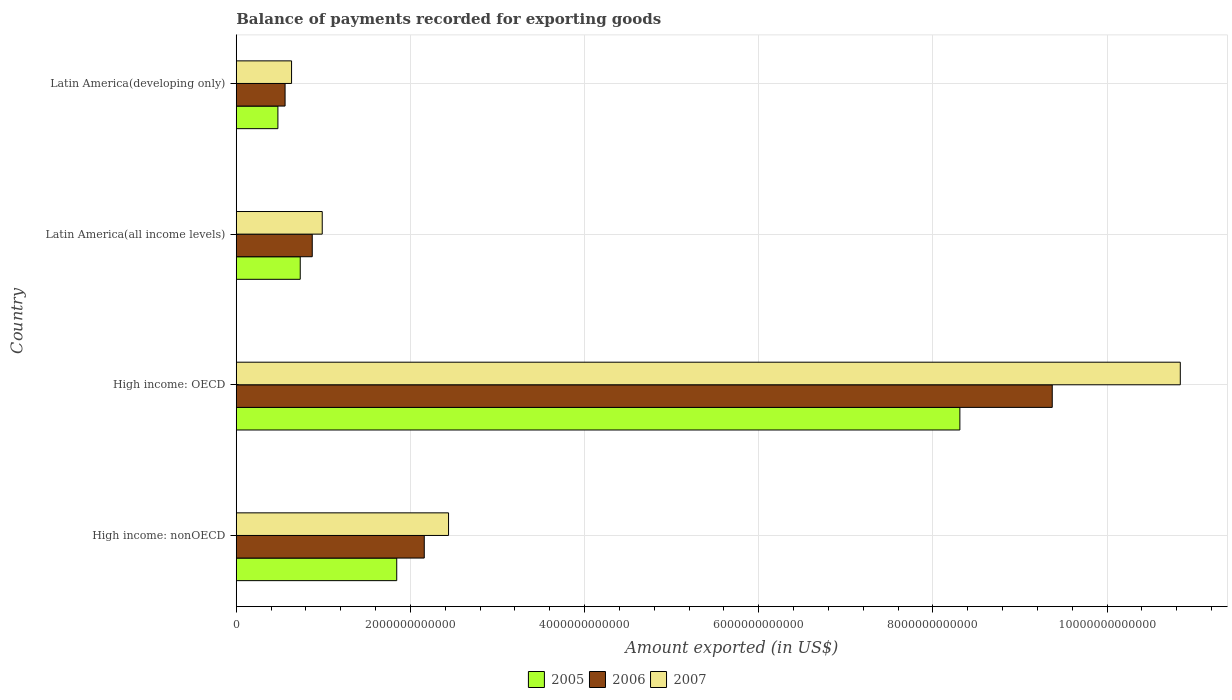How many different coloured bars are there?
Keep it short and to the point. 3. How many groups of bars are there?
Provide a succinct answer. 4. How many bars are there on the 3rd tick from the bottom?
Give a very brief answer. 3. What is the label of the 1st group of bars from the top?
Provide a short and direct response. Latin America(developing only). In how many cases, is the number of bars for a given country not equal to the number of legend labels?
Your answer should be compact. 0. What is the amount exported in 2007 in High income: OECD?
Make the answer very short. 1.08e+13. Across all countries, what is the maximum amount exported in 2005?
Your answer should be very brief. 8.31e+12. Across all countries, what is the minimum amount exported in 2006?
Make the answer very short. 5.61e+11. In which country was the amount exported in 2007 maximum?
Keep it short and to the point. High income: OECD. In which country was the amount exported in 2005 minimum?
Make the answer very short. Latin America(developing only). What is the total amount exported in 2006 in the graph?
Offer a very short reply. 1.30e+13. What is the difference between the amount exported in 2005 in High income: OECD and that in Latin America(developing only)?
Make the answer very short. 7.83e+12. What is the difference between the amount exported in 2007 in High income: OECD and the amount exported in 2005 in Latin America(all income levels)?
Make the answer very short. 1.01e+13. What is the average amount exported in 2007 per country?
Offer a terse response. 3.73e+12. What is the difference between the amount exported in 2006 and amount exported in 2007 in Latin America(developing only)?
Your answer should be very brief. -7.45e+1. What is the ratio of the amount exported in 2007 in High income: OECD to that in Latin America(developing only)?
Keep it short and to the point. 17.07. Is the amount exported in 2007 in Latin America(all income levels) less than that in Latin America(developing only)?
Keep it short and to the point. No. Is the difference between the amount exported in 2006 in High income: OECD and Latin America(all income levels) greater than the difference between the amount exported in 2007 in High income: OECD and Latin America(all income levels)?
Ensure brevity in your answer.  No. What is the difference between the highest and the second highest amount exported in 2007?
Offer a terse response. 8.40e+12. What is the difference between the highest and the lowest amount exported in 2007?
Ensure brevity in your answer.  1.02e+13. Is the sum of the amount exported in 2006 in High income: OECD and Latin America(all income levels) greater than the maximum amount exported in 2005 across all countries?
Give a very brief answer. Yes. How many countries are there in the graph?
Make the answer very short. 4. What is the difference between two consecutive major ticks on the X-axis?
Your response must be concise. 2.00e+12. Are the values on the major ticks of X-axis written in scientific E-notation?
Your response must be concise. No. Where does the legend appear in the graph?
Make the answer very short. Bottom center. How are the legend labels stacked?
Your answer should be very brief. Horizontal. What is the title of the graph?
Ensure brevity in your answer.  Balance of payments recorded for exporting goods. What is the label or title of the X-axis?
Your response must be concise. Amount exported (in US$). What is the label or title of the Y-axis?
Your answer should be compact. Country. What is the Amount exported (in US$) in 2005 in High income: nonOECD?
Your response must be concise. 1.84e+12. What is the Amount exported (in US$) of 2006 in High income: nonOECD?
Ensure brevity in your answer.  2.16e+12. What is the Amount exported (in US$) in 2007 in High income: nonOECD?
Provide a succinct answer. 2.44e+12. What is the Amount exported (in US$) of 2005 in High income: OECD?
Provide a short and direct response. 8.31e+12. What is the Amount exported (in US$) of 2006 in High income: OECD?
Your answer should be compact. 9.37e+12. What is the Amount exported (in US$) in 2007 in High income: OECD?
Make the answer very short. 1.08e+13. What is the Amount exported (in US$) of 2005 in Latin America(all income levels)?
Keep it short and to the point. 7.35e+11. What is the Amount exported (in US$) of 2006 in Latin America(all income levels)?
Provide a short and direct response. 8.73e+11. What is the Amount exported (in US$) in 2007 in Latin America(all income levels)?
Your response must be concise. 9.87e+11. What is the Amount exported (in US$) of 2005 in Latin America(developing only)?
Offer a very short reply. 4.78e+11. What is the Amount exported (in US$) in 2006 in Latin America(developing only)?
Keep it short and to the point. 5.61e+11. What is the Amount exported (in US$) of 2007 in Latin America(developing only)?
Your answer should be very brief. 6.35e+11. Across all countries, what is the maximum Amount exported (in US$) of 2005?
Your answer should be compact. 8.31e+12. Across all countries, what is the maximum Amount exported (in US$) in 2006?
Keep it short and to the point. 9.37e+12. Across all countries, what is the maximum Amount exported (in US$) of 2007?
Offer a terse response. 1.08e+13. Across all countries, what is the minimum Amount exported (in US$) of 2005?
Offer a very short reply. 4.78e+11. Across all countries, what is the minimum Amount exported (in US$) in 2006?
Ensure brevity in your answer.  5.61e+11. Across all countries, what is the minimum Amount exported (in US$) of 2007?
Give a very brief answer. 6.35e+11. What is the total Amount exported (in US$) of 2005 in the graph?
Your response must be concise. 1.14e+13. What is the total Amount exported (in US$) in 2006 in the graph?
Your response must be concise. 1.30e+13. What is the total Amount exported (in US$) of 2007 in the graph?
Your answer should be compact. 1.49e+13. What is the difference between the Amount exported (in US$) of 2005 in High income: nonOECD and that in High income: OECD?
Provide a succinct answer. -6.47e+12. What is the difference between the Amount exported (in US$) in 2006 in High income: nonOECD and that in High income: OECD?
Your response must be concise. -7.21e+12. What is the difference between the Amount exported (in US$) of 2007 in High income: nonOECD and that in High income: OECD?
Your answer should be very brief. -8.40e+12. What is the difference between the Amount exported (in US$) of 2005 in High income: nonOECD and that in Latin America(all income levels)?
Give a very brief answer. 1.11e+12. What is the difference between the Amount exported (in US$) of 2006 in High income: nonOECD and that in Latin America(all income levels)?
Make the answer very short. 1.29e+12. What is the difference between the Amount exported (in US$) in 2007 in High income: nonOECD and that in Latin America(all income levels)?
Keep it short and to the point. 1.45e+12. What is the difference between the Amount exported (in US$) in 2005 in High income: nonOECD and that in Latin America(developing only)?
Offer a very short reply. 1.36e+12. What is the difference between the Amount exported (in US$) of 2006 in High income: nonOECD and that in Latin America(developing only)?
Provide a short and direct response. 1.60e+12. What is the difference between the Amount exported (in US$) in 2007 in High income: nonOECD and that in Latin America(developing only)?
Your answer should be compact. 1.80e+12. What is the difference between the Amount exported (in US$) in 2005 in High income: OECD and that in Latin America(all income levels)?
Offer a terse response. 7.58e+12. What is the difference between the Amount exported (in US$) of 2006 in High income: OECD and that in Latin America(all income levels)?
Your answer should be very brief. 8.50e+12. What is the difference between the Amount exported (in US$) of 2007 in High income: OECD and that in Latin America(all income levels)?
Provide a succinct answer. 9.85e+12. What is the difference between the Amount exported (in US$) of 2005 in High income: OECD and that in Latin America(developing only)?
Make the answer very short. 7.83e+12. What is the difference between the Amount exported (in US$) in 2006 in High income: OECD and that in Latin America(developing only)?
Provide a succinct answer. 8.81e+12. What is the difference between the Amount exported (in US$) of 2007 in High income: OECD and that in Latin America(developing only)?
Keep it short and to the point. 1.02e+13. What is the difference between the Amount exported (in US$) of 2005 in Latin America(all income levels) and that in Latin America(developing only)?
Keep it short and to the point. 2.57e+11. What is the difference between the Amount exported (in US$) of 2006 in Latin America(all income levels) and that in Latin America(developing only)?
Ensure brevity in your answer.  3.12e+11. What is the difference between the Amount exported (in US$) in 2007 in Latin America(all income levels) and that in Latin America(developing only)?
Your answer should be compact. 3.52e+11. What is the difference between the Amount exported (in US$) of 2005 in High income: nonOECD and the Amount exported (in US$) of 2006 in High income: OECD?
Keep it short and to the point. -7.53e+12. What is the difference between the Amount exported (in US$) in 2005 in High income: nonOECD and the Amount exported (in US$) in 2007 in High income: OECD?
Your answer should be compact. -9.00e+12. What is the difference between the Amount exported (in US$) of 2006 in High income: nonOECD and the Amount exported (in US$) of 2007 in High income: OECD?
Provide a succinct answer. -8.68e+12. What is the difference between the Amount exported (in US$) of 2005 in High income: nonOECD and the Amount exported (in US$) of 2006 in Latin America(all income levels)?
Your answer should be very brief. 9.70e+11. What is the difference between the Amount exported (in US$) in 2005 in High income: nonOECD and the Amount exported (in US$) in 2007 in Latin America(all income levels)?
Ensure brevity in your answer.  8.55e+11. What is the difference between the Amount exported (in US$) of 2006 in High income: nonOECD and the Amount exported (in US$) of 2007 in Latin America(all income levels)?
Provide a short and direct response. 1.17e+12. What is the difference between the Amount exported (in US$) of 2005 in High income: nonOECD and the Amount exported (in US$) of 2006 in Latin America(developing only)?
Your response must be concise. 1.28e+12. What is the difference between the Amount exported (in US$) of 2005 in High income: nonOECD and the Amount exported (in US$) of 2007 in Latin America(developing only)?
Offer a very short reply. 1.21e+12. What is the difference between the Amount exported (in US$) of 2006 in High income: nonOECD and the Amount exported (in US$) of 2007 in Latin America(developing only)?
Provide a short and direct response. 1.52e+12. What is the difference between the Amount exported (in US$) in 2005 in High income: OECD and the Amount exported (in US$) in 2006 in Latin America(all income levels)?
Your answer should be very brief. 7.44e+12. What is the difference between the Amount exported (in US$) in 2005 in High income: OECD and the Amount exported (in US$) in 2007 in Latin America(all income levels)?
Offer a terse response. 7.32e+12. What is the difference between the Amount exported (in US$) in 2006 in High income: OECD and the Amount exported (in US$) in 2007 in Latin America(all income levels)?
Offer a very short reply. 8.38e+12. What is the difference between the Amount exported (in US$) in 2005 in High income: OECD and the Amount exported (in US$) in 2006 in Latin America(developing only)?
Make the answer very short. 7.75e+12. What is the difference between the Amount exported (in US$) of 2005 in High income: OECD and the Amount exported (in US$) of 2007 in Latin America(developing only)?
Provide a succinct answer. 7.67e+12. What is the difference between the Amount exported (in US$) of 2006 in High income: OECD and the Amount exported (in US$) of 2007 in Latin America(developing only)?
Provide a succinct answer. 8.74e+12. What is the difference between the Amount exported (in US$) in 2005 in Latin America(all income levels) and the Amount exported (in US$) in 2006 in Latin America(developing only)?
Give a very brief answer. 1.74e+11. What is the difference between the Amount exported (in US$) in 2005 in Latin America(all income levels) and the Amount exported (in US$) in 2007 in Latin America(developing only)?
Your answer should be compact. 9.97e+1. What is the difference between the Amount exported (in US$) of 2006 in Latin America(all income levels) and the Amount exported (in US$) of 2007 in Latin America(developing only)?
Your answer should be very brief. 2.38e+11. What is the average Amount exported (in US$) in 2005 per country?
Offer a terse response. 2.84e+12. What is the average Amount exported (in US$) in 2006 per country?
Make the answer very short. 3.24e+12. What is the average Amount exported (in US$) of 2007 per country?
Your answer should be compact. 3.73e+12. What is the difference between the Amount exported (in US$) of 2005 and Amount exported (in US$) of 2006 in High income: nonOECD?
Provide a short and direct response. -3.16e+11. What is the difference between the Amount exported (in US$) of 2005 and Amount exported (in US$) of 2007 in High income: nonOECD?
Offer a very short reply. -5.95e+11. What is the difference between the Amount exported (in US$) in 2006 and Amount exported (in US$) in 2007 in High income: nonOECD?
Your answer should be very brief. -2.79e+11. What is the difference between the Amount exported (in US$) in 2005 and Amount exported (in US$) in 2006 in High income: OECD?
Provide a succinct answer. -1.06e+12. What is the difference between the Amount exported (in US$) of 2005 and Amount exported (in US$) of 2007 in High income: OECD?
Make the answer very short. -2.53e+12. What is the difference between the Amount exported (in US$) of 2006 and Amount exported (in US$) of 2007 in High income: OECD?
Your answer should be very brief. -1.47e+12. What is the difference between the Amount exported (in US$) in 2005 and Amount exported (in US$) in 2006 in Latin America(all income levels)?
Provide a succinct answer. -1.38e+11. What is the difference between the Amount exported (in US$) of 2005 and Amount exported (in US$) of 2007 in Latin America(all income levels)?
Ensure brevity in your answer.  -2.53e+11. What is the difference between the Amount exported (in US$) of 2006 and Amount exported (in US$) of 2007 in Latin America(all income levels)?
Provide a short and direct response. -1.15e+11. What is the difference between the Amount exported (in US$) of 2005 and Amount exported (in US$) of 2006 in Latin America(developing only)?
Provide a succinct answer. -8.23e+1. What is the difference between the Amount exported (in US$) in 2005 and Amount exported (in US$) in 2007 in Latin America(developing only)?
Make the answer very short. -1.57e+11. What is the difference between the Amount exported (in US$) of 2006 and Amount exported (in US$) of 2007 in Latin America(developing only)?
Provide a succinct answer. -7.45e+1. What is the ratio of the Amount exported (in US$) in 2005 in High income: nonOECD to that in High income: OECD?
Keep it short and to the point. 0.22. What is the ratio of the Amount exported (in US$) in 2006 in High income: nonOECD to that in High income: OECD?
Your response must be concise. 0.23. What is the ratio of the Amount exported (in US$) of 2007 in High income: nonOECD to that in High income: OECD?
Offer a very short reply. 0.22. What is the ratio of the Amount exported (in US$) of 2005 in High income: nonOECD to that in Latin America(all income levels)?
Your answer should be compact. 2.51. What is the ratio of the Amount exported (in US$) in 2006 in High income: nonOECD to that in Latin America(all income levels)?
Ensure brevity in your answer.  2.47. What is the ratio of the Amount exported (in US$) in 2007 in High income: nonOECD to that in Latin America(all income levels)?
Offer a very short reply. 2.47. What is the ratio of the Amount exported (in US$) in 2005 in High income: nonOECD to that in Latin America(developing only)?
Make the answer very short. 3.85. What is the ratio of the Amount exported (in US$) in 2006 in High income: nonOECD to that in Latin America(developing only)?
Your answer should be very brief. 3.85. What is the ratio of the Amount exported (in US$) of 2007 in High income: nonOECD to that in Latin America(developing only)?
Ensure brevity in your answer.  3.84. What is the ratio of the Amount exported (in US$) in 2005 in High income: OECD to that in Latin America(all income levels)?
Make the answer very short. 11.31. What is the ratio of the Amount exported (in US$) of 2006 in High income: OECD to that in Latin America(all income levels)?
Your answer should be compact. 10.74. What is the ratio of the Amount exported (in US$) of 2007 in High income: OECD to that in Latin America(all income levels)?
Make the answer very short. 10.98. What is the ratio of the Amount exported (in US$) of 2005 in High income: OECD to that in Latin America(developing only)?
Give a very brief answer. 17.37. What is the ratio of the Amount exported (in US$) of 2006 in High income: OECD to that in Latin America(developing only)?
Offer a terse response. 16.71. What is the ratio of the Amount exported (in US$) in 2007 in High income: OECD to that in Latin America(developing only)?
Your response must be concise. 17.07. What is the ratio of the Amount exported (in US$) in 2005 in Latin America(all income levels) to that in Latin America(developing only)?
Ensure brevity in your answer.  1.54. What is the ratio of the Amount exported (in US$) of 2006 in Latin America(all income levels) to that in Latin America(developing only)?
Give a very brief answer. 1.56. What is the ratio of the Amount exported (in US$) of 2007 in Latin America(all income levels) to that in Latin America(developing only)?
Provide a short and direct response. 1.55. What is the difference between the highest and the second highest Amount exported (in US$) of 2005?
Keep it short and to the point. 6.47e+12. What is the difference between the highest and the second highest Amount exported (in US$) in 2006?
Keep it short and to the point. 7.21e+12. What is the difference between the highest and the second highest Amount exported (in US$) in 2007?
Make the answer very short. 8.40e+12. What is the difference between the highest and the lowest Amount exported (in US$) in 2005?
Offer a terse response. 7.83e+12. What is the difference between the highest and the lowest Amount exported (in US$) of 2006?
Your answer should be compact. 8.81e+12. What is the difference between the highest and the lowest Amount exported (in US$) in 2007?
Your answer should be very brief. 1.02e+13. 